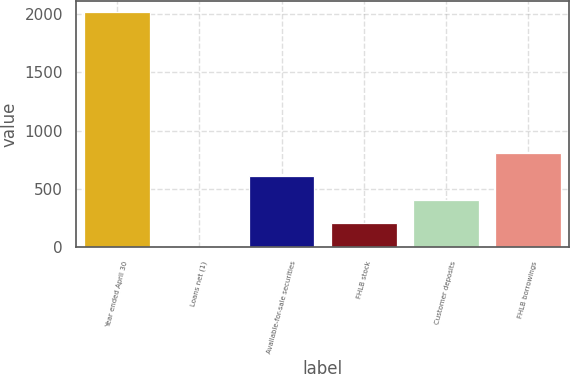Convert chart to OTSL. <chart><loc_0><loc_0><loc_500><loc_500><bar_chart><fcel>Year ended April 30<fcel>Loans net (1)<fcel>Available-for-sale securities<fcel>FHLB stock<fcel>Customer deposits<fcel>FHLB borrowings<nl><fcel>2012<fcel>5<fcel>607.1<fcel>205.7<fcel>406.4<fcel>807.8<nl></chart> 